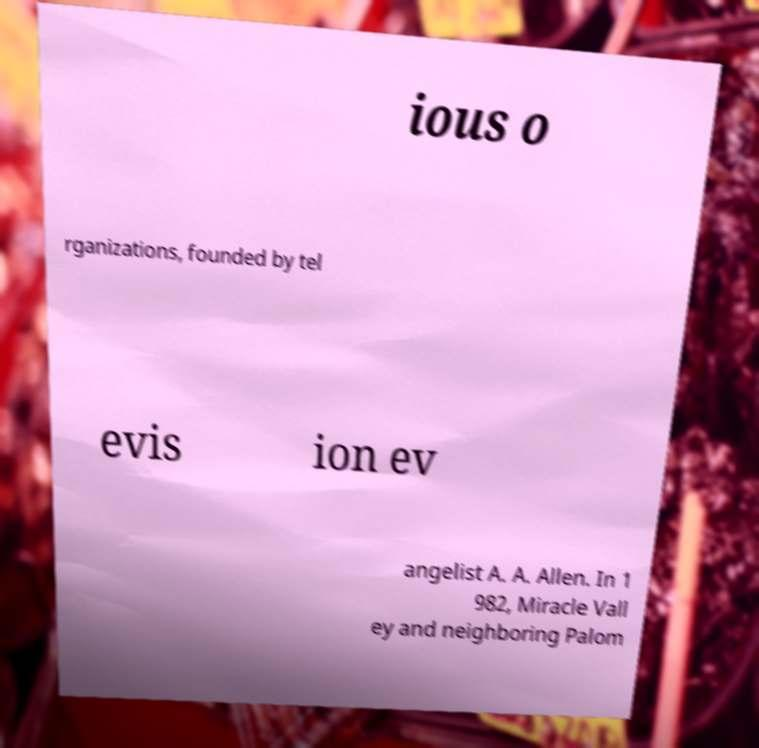For documentation purposes, I need the text within this image transcribed. Could you provide that? ious o rganizations, founded by tel evis ion ev angelist A. A. Allen. In 1 982, Miracle Vall ey and neighboring Palom 